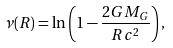<formula> <loc_0><loc_0><loc_500><loc_500>\nu ( R ) = \ln \left ( 1 - \frac { 2 G M _ { G } } { R c ^ { 2 } } \right ) ,</formula> 